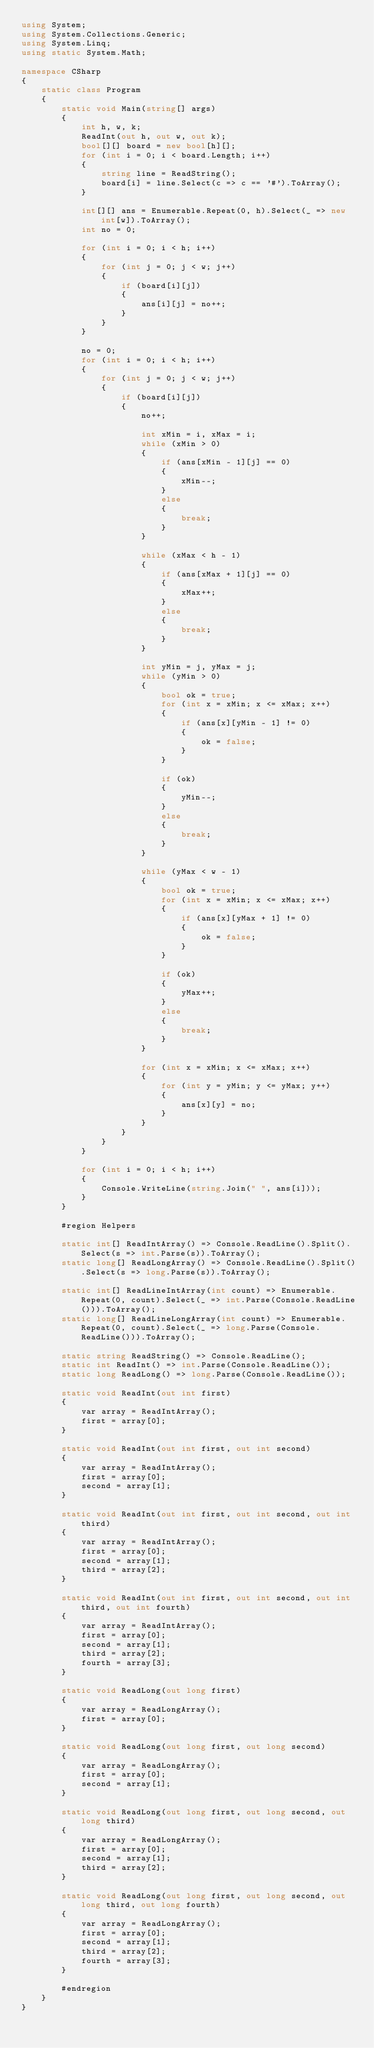<code> <loc_0><loc_0><loc_500><loc_500><_C#_>using System;
using System.Collections.Generic;
using System.Linq;
using static System.Math;

namespace CSharp
{
    static class Program
    {
        static void Main(string[] args)
        {
            int h, w, k;
            ReadInt(out h, out w, out k);
            bool[][] board = new bool[h][];
            for (int i = 0; i < board.Length; i++)
            {
                string line = ReadString();
                board[i] = line.Select(c => c == '#').ToArray();
            }

            int[][] ans = Enumerable.Repeat(0, h).Select(_ => new int[w]).ToArray();
            int no = 0;

            for (int i = 0; i < h; i++)
            {
                for (int j = 0; j < w; j++)
                {
                    if (board[i][j])
                    {
                        ans[i][j] = no++;
                    }
                }
            }

            no = 0;
            for (int i = 0; i < h; i++)
            {
                for (int j = 0; j < w; j++)
                {
                    if (board[i][j])
                    {
                        no++;

                        int xMin = i, xMax = i;
                        while (xMin > 0)
                        {
                            if (ans[xMin - 1][j] == 0)
                            {
                                xMin--;
                            }
                            else
                            {
                                break;
                            }
                        }

                        while (xMax < h - 1)
                        {
                            if (ans[xMax + 1][j] == 0)
                            {
                                xMax++;
                            }
                            else
                            {
                                break;
                            }
                        }

                        int yMin = j, yMax = j;
                        while (yMin > 0)
                        {
                            bool ok = true;
                            for (int x = xMin; x <= xMax; x++)
                            {
                                if (ans[x][yMin - 1] != 0)
                                {
                                    ok = false;
                                }
                            }

                            if (ok)
                            {
                                yMin--;
                            }
                            else
                            {
                                break;
                            }
                        }

                        while (yMax < w - 1)
                        {
                            bool ok = true;
                            for (int x = xMin; x <= xMax; x++)
                            {
                                if (ans[x][yMax + 1] != 0)
                                {
                                    ok = false;
                                }
                            }

                            if (ok)
                            {
                                yMax++;
                            }
                            else
                            {
                                break;
                            }
                        }

                        for (int x = xMin; x <= xMax; x++)
                        {
                            for (int y = yMin; y <= yMax; y++)
                            {
                                ans[x][y] = no;
                            }
                        }
                    }
                }
            }

            for (int i = 0; i < h; i++)
            {
                Console.WriteLine(string.Join(" ", ans[i]));
            }
        }

        #region Helpers

        static int[] ReadIntArray() => Console.ReadLine().Split().Select(s => int.Parse(s)).ToArray();
        static long[] ReadLongArray() => Console.ReadLine().Split().Select(s => long.Parse(s)).ToArray();

        static int[] ReadLineIntArray(int count) => Enumerable.Repeat(0, count).Select(_ => int.Parse(Console.ReadLine())).ToArray();
        static long[] ReadLineLongArray(int count) => Enumerable.Repeat(0, count).Select(_ => long.Parse(Console.ReadLine())).ToArray();

        static string ReadString() => Console.ReadLine();
        static int ReadInt() => int.Parse(Console.ReadLine());
        static long ReadLong() => long.Parse(Console.ReadLine());

        static void ReadInt(out int first)
        {
            var array = ReadIntArray();
            first = array[0];
        }

        static void ReadInt(out int first, out int second)
        {
            var array = ReadIntArray();
            first = array[0];
            second = array[1];
        }

        static void ReadInt(out int first, out int second, out int third)
        {
            var array = ReadIntArray();
            first = array[0];
            second = array[1];
            third = array[2];
        }

        static void ReadInt(out int first, out int second, out int third, out int fourth)
        {
            var array = ReadIntArray();
            first = array[0];
            second = array[1];
            third = array[2];
            fourth = array[3];
        }

        static void ReadLong(out long first)
        {
            var array = ReadLongArray();
            first = array[0];
        }

        static void ReadLong(out long first, out long second)
        {
            var array = ReadLongArray();
            first = array[0];
            second = array[1];
        }

        static void ReadLong(out long first, out long second, out long third)
        {
            var array = ReadLongArray();
            first = array[0];
            second = array[1];
            third = array[2];
        }

        static void ReadLong(out long first, out long second, out long third, out long fourth)
        {
            var array = ReadLongArray();
            first = array[0];
            second = array[1];
            third = array[2];
            fourth = array[3];
        }

        #endregion
    }
}</code> 